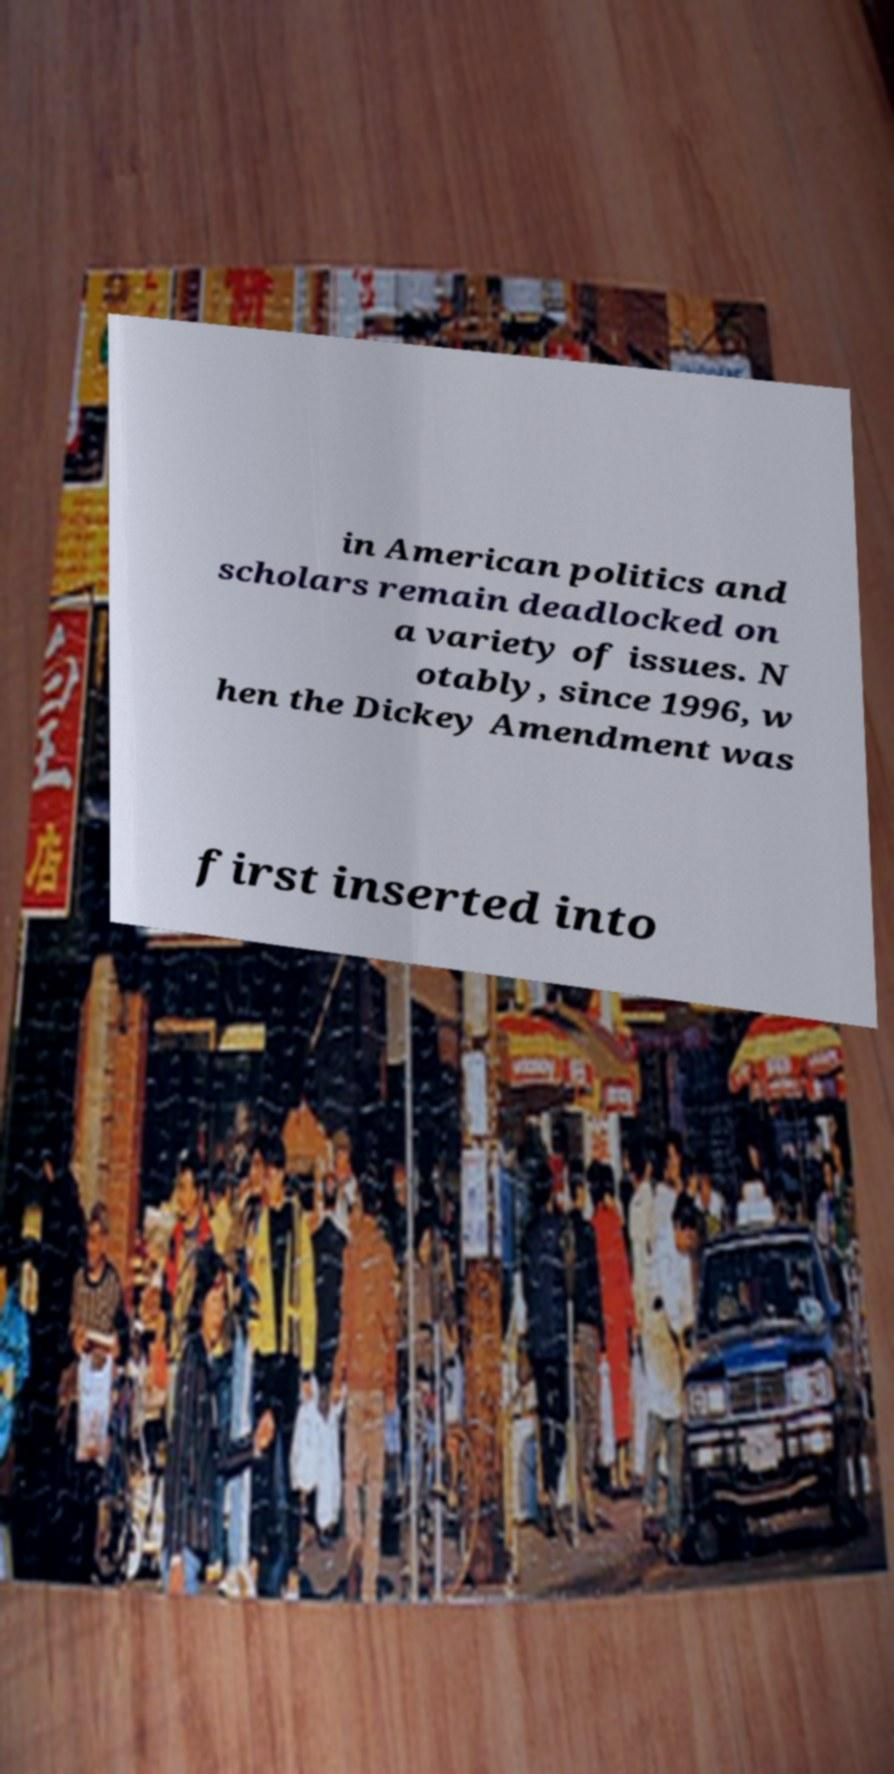Please identify and transcribe the text found in this image. in American politics and scholars remain deadlocked on a variety of issues. N otably, since 1996, w hen the Dickey Amendment was first inserted into 